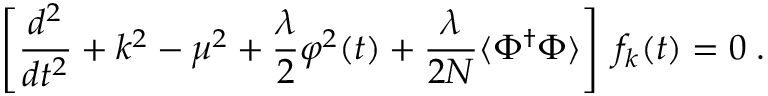Convert formula to latex. <formula><loc_0><loc_0><loc_500><loc_500>\left [ \frac { d ^ { 2 } } { d t ^ { 2 } } + k ^ { 2 } - \mu ^ { 2 } + \frac { \lambda } { 2 } \varphi ^ { 2 } ( t ) + \frac { \lambda } { 2 N } \langle \Phi ^ { \dagger } \Phi \rangle \right ] \, f _ { k } ( t ) = 0 \, .</formula> 